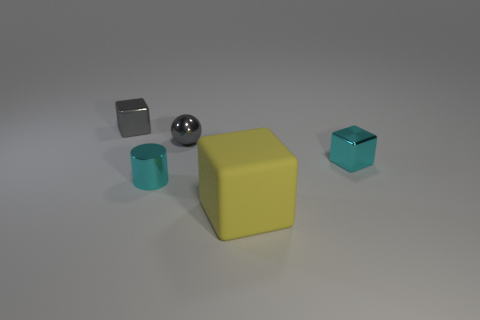Do the ball and the small metal cylinder have the same color? No, they do not share the same color. The ball has a shiny, reflective silver color, while the small metal cylinder appears to be a non-reflective dark gray. The difference in color and reflectivity highlights the varying materials and surface properties between the two objects. 